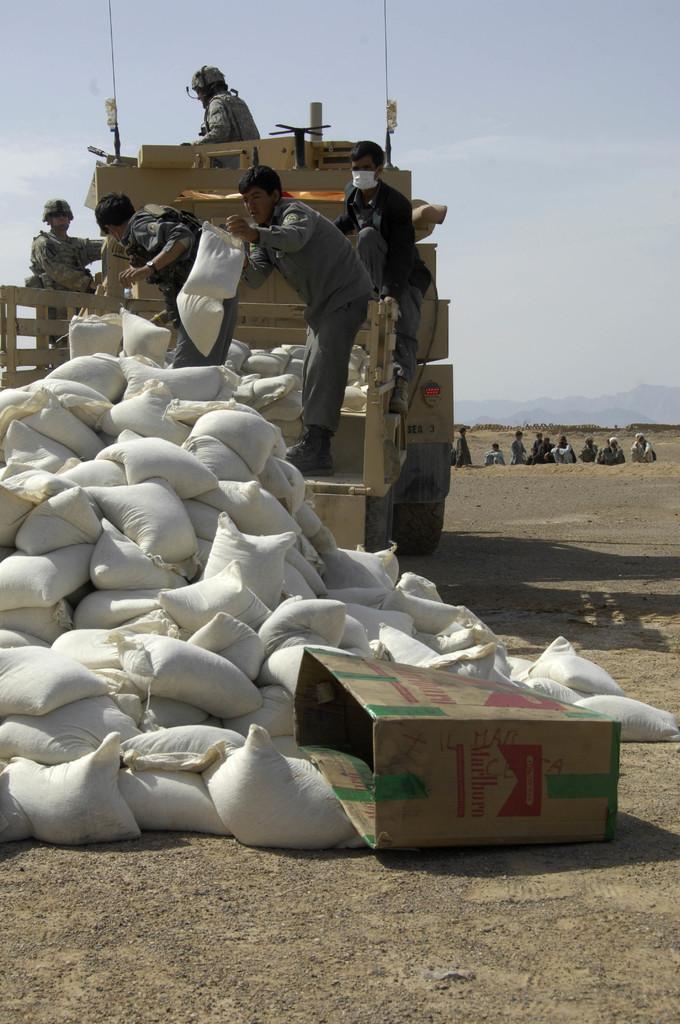Can you describe this image briefly? In this image there is one vehicle in that vehicle there are some bags and some persons are standing and they are holding bags, and on the right side there are some bags and one box. In the background there are some people and mountains, at the bottom there is walkway and at the top there is sky. 